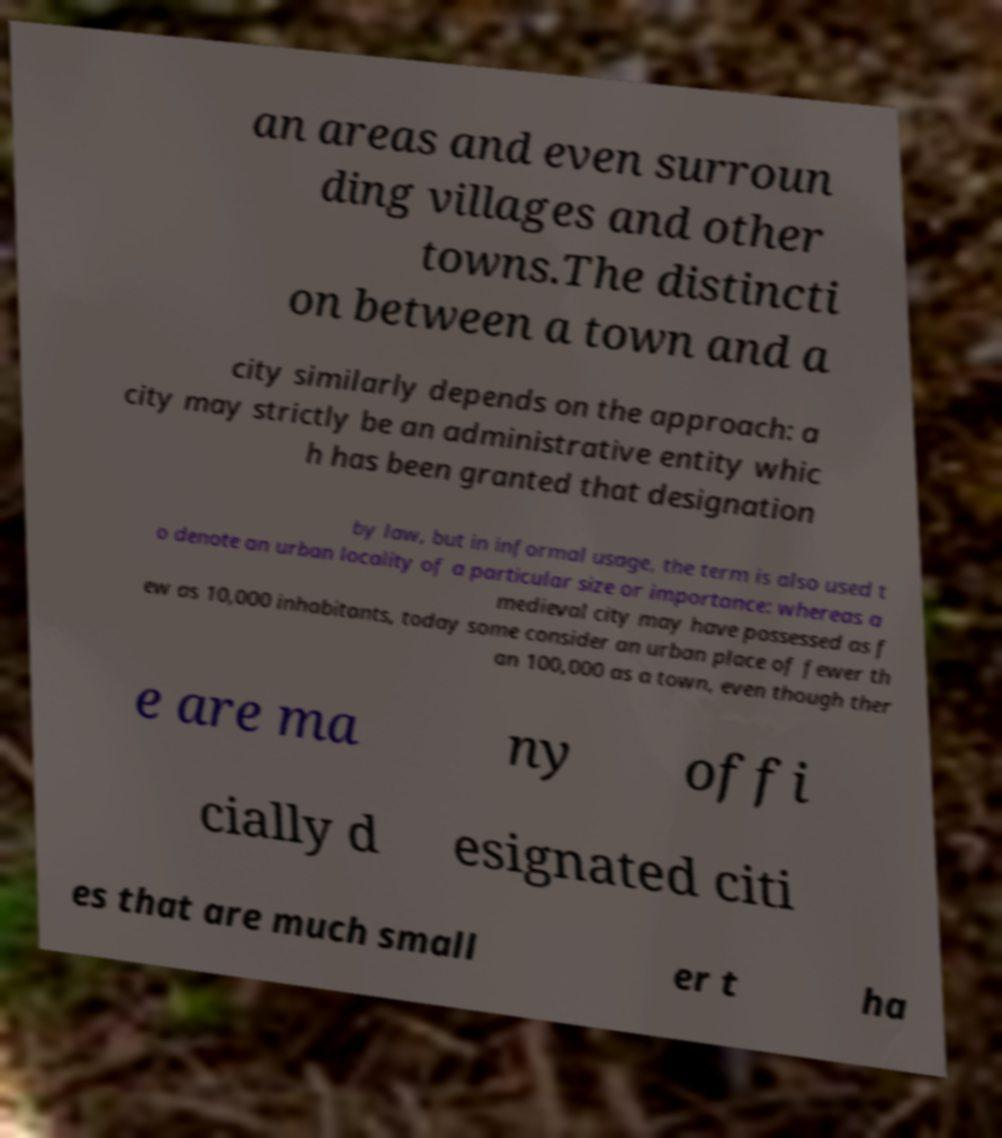Could you extract and type out the text from this image? an areas and even surroun ding villages and other towns.The distincti on between a town and a city similarly depends on the approach: a city may strictly be an administrative entity whic h has been granted that designation by law, but in informal usage, the term is also used t o denote an urban locality of a particular size or importance: whereas a medieval city may have possessed as f ew as 10,000 inhabitants, today some consider an urban place of fewer th an 100,000 as a town, even though ther e are ma ny offi cially d esignated citi es that are much small er t ha 